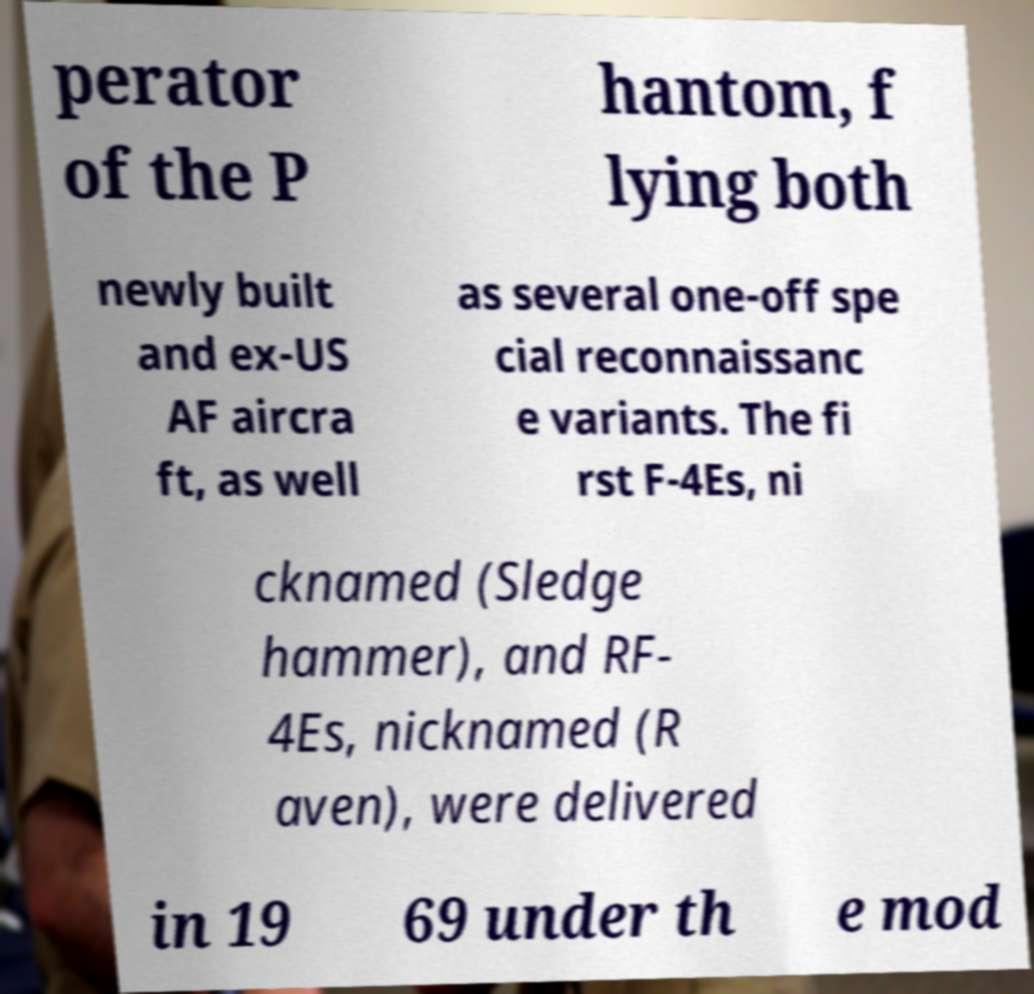Please read and relay the text visible in this image. What does it say? perator of the P hantom, f lying both newly built and ex-US AF aircra ft, as well as several one-off spe cial reconnaissanc e variants. The fi rst F-4Es, ni cknamed (Sledge hammer), and RF- 4Es, nicknamed (R aven), were delivered in 19 69 under th e mod 